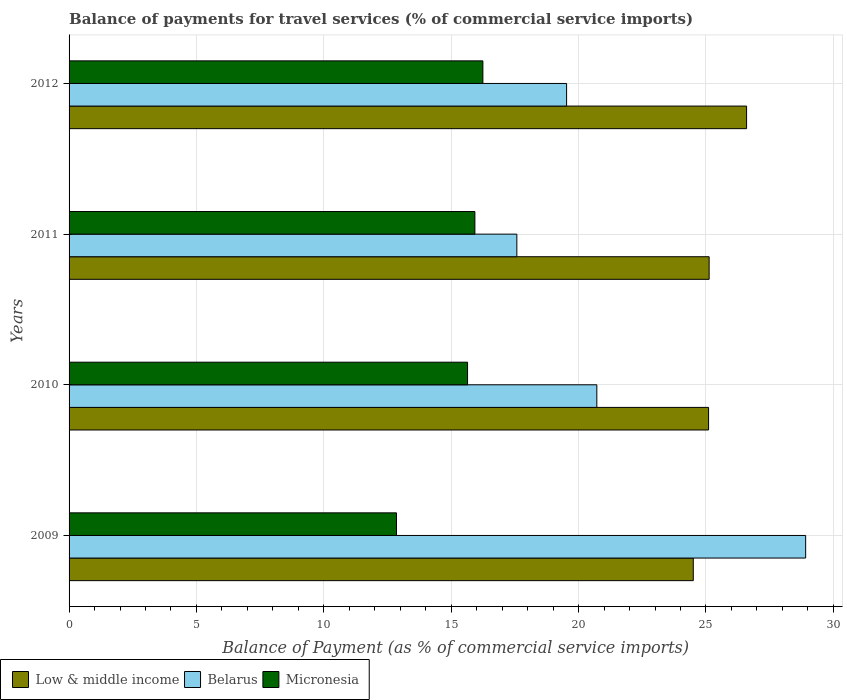How many groups of bars are there?
Keep it short and to the point. 4. Are the number of bars on each tick of the Y-axis equal?
Your response must be concise. Yes. How many bars are there on the 2nd tick from the bottom?
Ensure brevity in your answer.  3. What is the label of the 4th group of bars from the top?
Ensure brevity in your answer.  2009. In how many cases, is the number of bars for a given year not equal to the number of legend labels?
Your answer should be very brief. 0. What is the balance of payments for travel services in Belarus in 2011?
Keep it short and to the point. 17.58. Across all years, what is the maximum balance of payments for travel services in Low & middle income?
Provide a succinct answer. 26.59. Across all years, what is the minimum balance of payments for travel services in Micronesia?
Provide a succinct answer. 12.85. What is the total balance of payments for travel services in Micronesia in the graph?
Ensure brevity in your answer.  60.67. What is the difference between the balance of payments for travel services in Low & middle income in 2011 and that in 2012?
Give a very brief answer. -1.47. What is the difference between the balance of payments for travel services in Low & middle income in 2010 and the balance of payments for travel services in Micronesia in 2012?
Your answer should be very brief. 8.86. What is the average balance of payments for travel services in Micronesia per year?
Provide a succinct answer. 15.17. In the year 2009, what is the difference between the balance of payments for travel services in Low & middle income and balance of payments for travel services in Belarus?
Offer a very short reply. -4.41. What is the ratio of the balance of payments for travel services in Micronesia in 2011 to that in 2012?
Your answer should be compact. 0.98. Is the balance of payments for travel services in Micronesia in 2009 less than that in 2012?
Your response must be concise. Yes. Is the difference between the balance of payments for travel services in Low & middle income in 2009 and 2012 greater than the difference between the balance of payments for travel services in Belarus in 2009 and 2012?
Provide a succinct answer. No. What is the difference between the highest and the second highest balance of payments for travel services in Belarus?
Ensure brevity in your answer.  8.2. What is the difference between the highest and the lowest balance of payments for travel services in Micronesia?
Make the answer very short. 3.39. In how many years, is the balance of payments for travel services in Low & middle income greater than the average balance of payments for travel services in Low & middle income taken over all years?
Your answer should be compact. 1. Is the sum of the balance of payments for travel services in Low & middle income in 2010 and 2011 greater than the maximum balance of payments for travel services in Belarus across all years?
Make the answer very short. Yes. What does the 3rd bar from the bottom in 2011 represents?
Provide a succinct answer. Micronesia. Are all the bars in the graph horizontal?
Offer a very short reply. Yes. Where does the legend appear in the graph?
Offer a terse response. Bottom left. How many legend labels are there?
Keep it short and to the point. 3. How are the legend labels stacked?
Your response must be concise. Horizontal. What is the title of the graph?
Provide a short and direct response. Balance of payments for travel services (% of commercial service imports). What is the label or title of the X-axis?
Ensure brevity in your answer.  Balance of Payment (as % of commercial service imports). What is the Balance of Payment (as % of commercial service imports) in Low & middle income in 2009?
Give a very brief answer. 24.5. What is the Balance of Payment (as % of commercial service imports) of Belarus in 2009?
Provide a short and direct response. 28.91. What is the Balance of Payment (as % of commercial service imports) in Micronesia in 2009?
Make the answer very short. 12.85. What is the Balance of Payment (as % of commercial service imports) in Low & middle income in 2010?
Give a very brief answer. 25.1. What is the Balance of Payment (as % of commercial service imports) of Belarus in 2010?
Ensure brevity in your answer.  20.72. What is the Balance of Payment (as % of commercial service imports) of Micronesia in 2010?
Make the answer very short. 15.64. What is the Balance of Payment (as % of commercial service imports) of Low & middle income in 2011?
Offer a very short reply. 25.12. What is the Balance of Payment (as % of commercial service imports) in Belarus in 2011?
Make the answer very short. 17.58. What is the Balance of Payment (as % of commercial service imports) in Micronesia in 2011?
Your answer should be compact. 15.93. What is the Balance of Payment (as % of commercial service imports) of Low & middle income in 2012?
Your response must be concise. 26.59. What is the Balance of Payment (as % of commercial service imports) of Belarus in 2012?
Keep it short and to the point. 19.53. What is the Balance of Payment (as % of commercial service imports) in Micronesia in 2012?
Your response must be concise. 16.24. Across all years, what is the maximum Balance of Payment (as % of commercial service imports) in Low & middle income?
Your answer should be compact. 26.59. Across all years, what is the maximum Balance of Payment (as % of commercial service imports) in Belarus?
Make the answer very short. 28.91. Across all years, what is the maximum Balance of Payment (as % of commercial service imports) of Micronesia?
Keep it short and to the point. 16.24. Across all years, what is the minimum Balance of Payment (as % of commercial service imports) in Low & middle income?
Give a very brief answer. 24.5. Across all years, what is the minimum Balance of Payment (as % of commercial service imports) in Belarus?
Offer a terse response. 17.58. Across all years, what is the minimum Balance of Payment (as % of commercial service imports) in Micronesia?
Provide a short and direct response. 12.85. What is the total Balance of Payment (as % of commercial service imports) in Low & middle income in the graph?
Provide a succinct answer. 101.32. What is the total Balance of Payment (as % of commercial service imports) in Belarus in the graph?
Make the answer very short. 86.74. What is the total Balance of Payment (as % of commercial service imports) in Micronesia in the graph?
Make the answer very short. 60.67. What is the difference between the Balance of Payment (as % of commercial service imports) in Low & middle income in 2009 and that in 2010?
Offer a very short reply. -0.6. What is the difference between the Balance of Payment (as % of commercial service imports) in Belarus in 2009 and that in 2010?
Ensure brevity in your answer.  8.2. What is the difference between the Balance of Payment (as % of commercial service imports) in Micronesia in 2009 and that in 2010?
Your answer should be very brief. -2.79. What is the difference between the Balance of Payment (as % of commercial service imports) in Low & middle income in 2009 and that in 2011?
Offer a very short reply. -0.62. What is the difference between the Balance of Payment (as % of commercial service imports) in Belarus in 2009 and that in 2011?
Give a very brief answer. 11.34. What is the difference between the Balance of Payment (as % of commercial service imports) in Micronesia in 2009 and that in 2011?
Provide a short and direct response. -3.08. What is the difference between the Balance of Payment (as % of commercial service imports) in Low & middle income in 2009 and that in 2012?
Your response must be concise. -2.09. What is the difference between the Balance of Payment (as % of commercial service imports) of Belarus in 2009 and that in 2012?
Provide a short and direct response. 9.38. What is the difference between the Balance of Payment (as % of commercial service imports) of Micronesia in 2009 and that in 2012?
Provide a short and direct response. -3.39. What is the difference between the Balance of Payment (as % of commercial service imports) of Low & middle income in 2010 and that in 2011?
Your response must be concise. -0.02. What is the difference between the Balance of Payment (as % of commercial service imports) of Belarus in 2010 and that in 2011?
Provide a short and direct response. 3.14. What is the difference between the Balance of Payment (as % of commercial service imports) in Micronesia in 2010 and that in 2011?
Provide a succinct answer. -0.29. What is the difference between the Balance of Payment (as % of commercial service imports) of Low & middle income in 2010 and that in 2012?
Offer a terse response. -1.49. What is the difference between the Balance of Payment (as % of commercial service imports) in Belarus in 2010 and that in 2012?
Provide a short and direct response. 1.19. What is the difference between the Balance of Payment (as % of commercial service imports) of Micronesia in 2010 and that in 2012?
Your answer should be very brief. -0.6. What is the difference between the Balance of Payment (as % of commercial service imports) in Low & middle income in 2011 and that in 2012?
Offer a terse response. -1.47. What is the difference between the Balance of Payment (as % of commercial service imports) in Belarus in 2011 and that in 2012?
Your answer should be very brief. -1.95. What is the difference between the Balance of Payment (as % of commercial service imports) of Micronesia in 2011 and that in 2012?
Ensure brevity in your answer.  -0.31. What is the difference between the Balance of Payment (as % of commercial service imports) in Low & middle income in 2009 and the Balance of Payment (as % of commercial service imports) in Belarus in 2010?
Offer a terse response. 3.79. What is the difference between the Balance of Payment (as % of commercial service imports) of Low & middle income in 2009 and the Balance of Payment (as % of commercial service imports) of Micronesia in 2010?
Your answer should be compact. 8.86. What is the difference between the Balance of Payment (as % of commercial service imports) of Belarus in 2009 and the Balance of Payment (as % of commercial service imports) of Micronesia in 2010?
Make the answer very short. 13.27. What is the difference between the Balance of Payment (as % of commercial service imports) of Low & middle income in 2009 and the Balance of Payment (as % of commercial service imports) of Belarus in 2011?
Your answer should be compact. 6.93. What is the difference between the Balance of Payment (as % of commercial service imports) of Low & middle income in 2009 and the Balance of Payment (as % of commercial service imports) of Micronesia in 2011?
Your answer should be very brief. 8.57. What is the difference between the Balance of Payment (as % of commercial service imports) in Belarus in 2009 and the Balance of Payment (as % of commercial service imports) in Micronesia in 2011?
Your answer should be compact. 12.98. What is the difference between the Balance of Payment (as % of commercial service imports) of Low & middle income in 2009 and the Balance of Payment (as % of commercial service imports) of Belarus in 2012?
Provide a succinct answer. 4.97. What is the difference between the Balance of Payment (as % of commercial service imports) of Low & middle income in 2009 and the Balance of Payment (as % of commercial service imports) of Micronesia in 2012?
Keep it short and to the point. 8.26. What is the difference between the Balance of Payment (as % of commercial service imports) in Belarus in 2009 and the Balance of Payment (as % of commercial service imports) in Micronesia in 2012?
Your answer should be compact. 12.67. What is the difference between the Balance of Payment (as % of commercial service imports) of Low & middle income in 2010 and the Balance of Payment (as % of commercial service imports) of Belarus in 2011?
Offer a very short reply. 7.53. What is the difference between the Balance of Payment (as % of commercial service imports) of Low & middle income in 2010 and the Balance of Payment (as % of commercial service imports) of Micronesia in 2011?
Your answer should be very brief. 9.17. What is the difference between the Balance of Payment (as % of commercial service imports) in Belarus in 2010 and the Balance of Payment (as % of commercial service imports) in Micronesia in 2011?
Your response must be concise. 4.79. What is the difference between the Balance of Payment (as % of commercial service imports) of Low & middle income in 2010 and the Balance of Payment (as % of commercial service imports) of Belarus in 2012?
Your answer should be very brief. 5.57. What is the difference between the Balance of Payment (as % of commercial service imports) of Low & middle income in 2010 and the Balance of Payment (as % of commercial service imports) of Micronesia in 2012?
Offer a terse response. 8.86. What is the difference between the Balance of Payment (as % of commercial service imports) in Belarus in 2010 and the Balance of Payment (as % of commercial service imports) in Micronesia in 2012?
Provide a short and direct response. 4.47. What is the difference between the Balance of Payment (as % of commercial service imports) in Low & middle income in 2011 and the Balance of Payment (as % of commercial service imports) in Belarus in 2012?
Offer a very short reply. 5.6. What is the difference between the Balance of Payment (as % of commercial service imports) in Low & middle income in 2011 and the Balance of Payment (as % of commercial service imports) in Micronesia in 2012?
Offer a terse response. 8.88. What is the difference between the Balance of Payment (as % of commercial service imports) of Belarus in 2011 and the Balance of Payment (as % of commercial service imports) of Micronesia in 2012?
Your answer should be very brief. 1.33. What is the average Balance of Payment (as % of commercial service imports) of Low & middle income per year?
Keep it short and to the point. 25.33. What is the average Balance of Payment (as % of commercial service imports) in Belarus per year?
Keep it short and to the point. 21.68. What is the average Balance of Payment (as % of commercial service imports) of Micronesia per year?
Provide a succinct answer. 15.17. In the year 2009, what is the difference between the Balance of Payment (as % of commercial service imports) in Low & middle income and Balance of Payment (as % of commercial service imports) in Belarus?
Make the answer very short. -4.41. In the year 2009, what is the difference between the Balance of Payment (as % of commercial service imports) in Low & middle income and Balance of Payment (as % of commercial service imports) in Micronesia?
Your response must be concise. 11.65. In the year 2009, what is the difference between the Balance of Payment (as % of commercial service imports) in Belarus and Balance of Payment (as % of commercial service imports) in Micronesia?
Keep it short and to the point. 16.06. In the year 2010, what is the difference between the Balance of Payment (as % of commercial service imports) in Low & middle income and Balance of Payment (as % of commercial service imports) in Belarus?
Ensure brevity in your answer.  4.39. In the year 2010, what is the difference between the Balance of Payment (as % of commercial service imports) of Low & middle income and Balance of Payment (as % of commercial service imports) of Micronesia?
Make the answer very short. 9.46. In the year 2010, what is the difference between the Balance of Payment (as % of commercial service imports) of Belarus and Balance of Payment (as % of commercial service imports) of Micronesia?
Your answer should be compact. 5.07. In the year 2011, what is the difference between the Balance of Payment (as % of commercial service imports) of Low & middle income and Balance of Payment (as % of commercial service imports) of Belarus?
Your response must be concise. 7.55. In the year 2011, what is the difference between the Balance of Payment (as % of commercial service imports) in Low & middle income and Balance of Payment (as % of commercial service imports) in Micronesia?
Offer a very short reply. 9.2. In the year 2011, what is the difference between the Balance of Payment (as % of commercial service imports) of Belarus and Balance of Payment (as % of commercial service imports) of Micronesia?
Provide a succinct answer. 1.65. In the year 2012, what is the difference between the Balance of Payment (as % of commercial service imports) of Low & middle income and Balance of Payment (as % of commercial service imports) of Belarus?
Provide a succinct answer. 7.07. In the year 2012, what is the difference between the Balance of Payment (as % of commercial service imports) of Low & middle income and Balance of Payment (as % of commercial service imports) of Micronesia?
Offer a terse response. 10.35. In the year 2012, what is the difference between the Balance of Payment (as % of commercial service imports) in Belarus and Balance of Payment (as % of commercial service imports) in Micronesia?
Offer a very short reply. 3.29. What is the ratio of the Balance of Payment (as % of commercial service imports) of Low & middle income in 2009 to that in 2010?
Offer a very short reply. 0.98. What is the ratio of the Balance of Payment (as % of commercial service imports) in Belarus in 2009 to that in 2010?
Make the answer very short. 1.4. What is the ratio of the Balance of Payment (as % of commercial service imports) of Micronesia in 2009 to that in 2010?
Your response must be concise. 0.82. What is the ratio of the Balance of Payment (as % of commercial service imports) of Low & middle income in 2009 to that in 2011?
Make the answer very short. 0.98. What is the ratio of the Balance of Payment (as % of commercial service imports) in Belarus in 2009 to that in 2011?
Ensure brevity in your answer.  1.65. What is the ratio of the Balance of Payment (as % of commercial service imports) in Micronesia in 2009 to that in 2011?
Give a very brief answer. 0.81. What is the ratio of the Balance of Payment (as % of commercial service imports) of Low & middle income in 2009 to that in 2012?
Ensure brevity in your answer.  0.92. What is the ratio of the Balance of Payment (as % of commercial service imports) in Belarus in 2009 to that in 2012?
Ensure brevity in your answer.  1.48. What is the ratio of the Balance of Payment (as % of commercial service imports) in Micronesia in 2009 to that in 2012?
Make the answer very short. 0.79. What is the ratio of the Balance of Payment (as % of commercial service imports) in Belarus in 2010 to that in 2011?
Offer a terse response. 1.18. What is the ratio of the Balance of Payment (as % of commercial service imports) of Micronesia in 2010 to that in 2011?
Your answer should be very brief. 0.98. What is the ratio of the Balance of Payment (as % of commercial service imports) in Low & middle income in 2010 to that in 2012?
Your response must be concise. 0.94. What is the ratio of the Balance of Payment (as % of commercial service imports) in Belarus in 2010 to that in 2012?
Give a very brief answer. 1.06. What is the ratio of the Balance of Payment (as % of commercial service imports) in Low & middle income in 2011 to that in 2012?
Your answer should be compact. 0.94. What is the ratio of the Balance of Payment (as % of commercial service imports) of Belarus in 2011 to that in 2012?
Your response must be concise. 0.9. What is the ratio of the Balance of Payment (as % of commercial service imports) in Micronesia in 2011 to that in 2012?
Give a very brief answer. 0.98. What is the difference between the highest and the second highest Balance of Payment (as % of commercial service imports) of Low & middle income?
Provide a succinct answer. 1.47. What is the difference between the highest and the second highest Balance of Payment (as % of commercial service imports) of Belarus?
Give a very brief answer. 8.2. What is the difference between the highest and the second highest Balance of Payment (as % of commercial service imports) of Micronesia?
Give a very brief answer. 0.31. What is the difference between the highest and the lowest Balance of Payment (as % of commercial service imports) in Low & middle income?
Provide a short and direct response. 2.09. What is the difference between the highest and the lowest Balance of Payment (as % of commercial service imports) of Belarus?
Ensure brevity in your answer.  11.34. What is the difference between the highest and the lowest Balance of Payment (as % of commercial service imports) in Micronesia?
Provide a succinct answer. 3.39. 